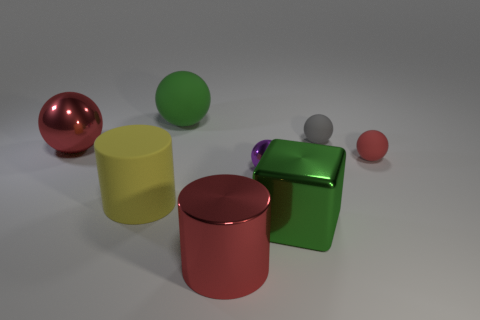Is the number of large red balls that are right of the metal cylinder less than the number of large shiny objects that are behind the green metal object?
Provide a short and direct response. Yes. There is a big matte cylinder; are there any large red metal spheres in front of it?
Offer a terse response. No. How many objects are red shiny objects behind the metallic block or large green metal things left of the tiny red ball?
Offer a terse response. 2. What number of shiny objects are the same color as the big rubber cylinder?
Give a very brief answer. 0. There is another big matte object that is the same shape as the gray rubber object; what is its color?
Offer a very short reply. Green. What shape is the rubber object that is both on the left side of the gray matte ball and in front of the big green matte ball?
Your answer should be very brief. Cylinder. Is the number of big yellow objects greater than the number of small matte objects?
Keep it short and to the point. No. What is the large block made of?
Keep it short and to the point. Metal. Is there anything else that is the same size as the green matte sphere?
Make the answer very short. Yes. There is a purple metal object that is the same shape as the tiny gray thing; what size is it?
Offer a very short reply. Small. 